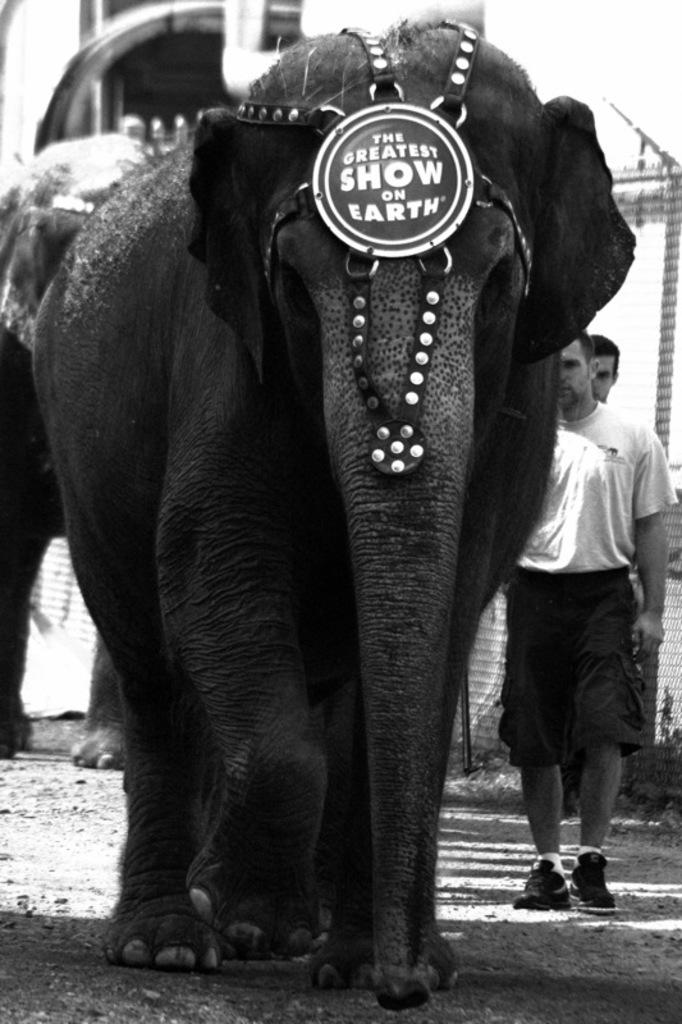What is the color scheme of the image? The image is black and white. What animals are present in the image? There are elephants in the image. Is there anything unique about one of the elephants? Yes, there is a logo on one of the elephants. What can be found on the logo? The logo has something written on it. Can you describe the background of the image? There are people visible in the background of the image. How many girls are playing with the appliance in the image? There are no girls or appliances present in the image; it features elephants with a logo. What type of stem is growing from the elephant's trunk in the image? There is no stem growing from the elephant's trunk in the image. 